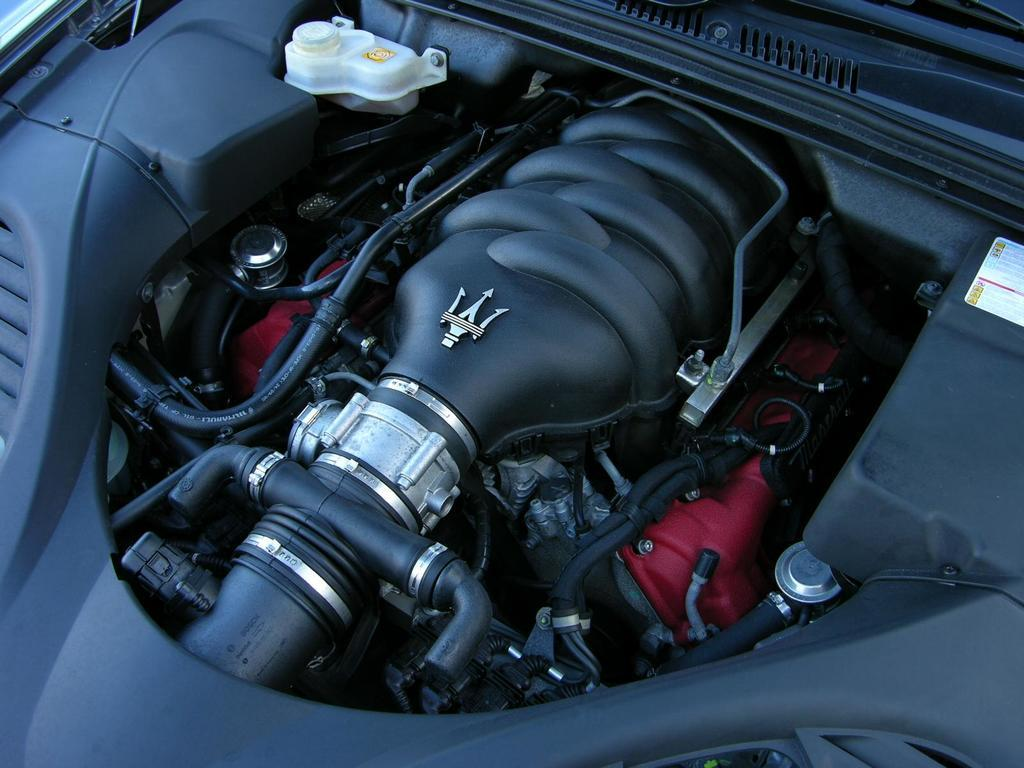What is the main subject of the image? The main subject of the image is a car engine. Can you describe any specific details about the car engine? Unfortunately, the image is zoomed in on the car engine, so it is difficult to see specific details. What type of story is being told on the sidewalk in the image? There is no sidewalk or story present in the image; it is a zoomed in image of a car engine. How many spiders can be seen crawling on the car engine in the image? There are no spiders present in the image; it is a zoomed in image of a car engine. 